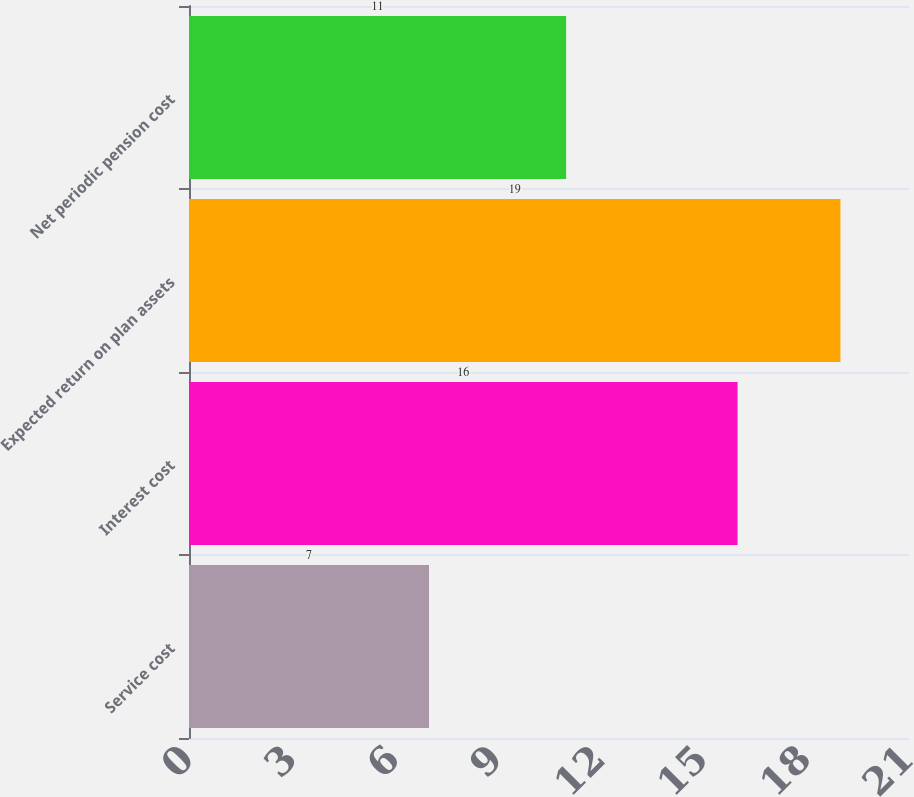Convert chart. <chart><loc_0><loc_0><loc_500><loc_500><bar_chart><fcel>Service cost<fcel>Interest cost<fcel>Expected return on plan assets<fcel>Net periodic pension cost<nl><fcel>7<fcel>16<fcel>19<fcel>11<nl></chart> 